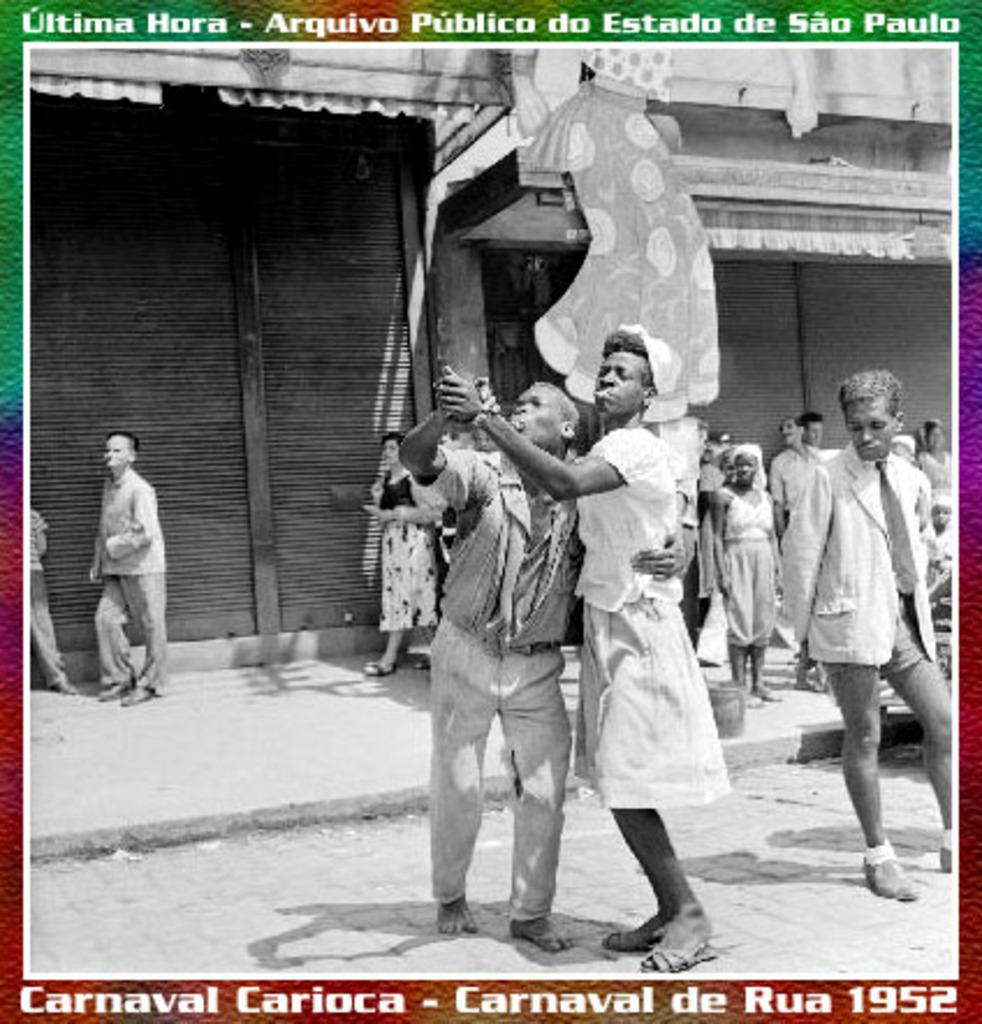What is present at the top and bottom of the image? There is text at the top and bottom of the image. What can be seen in the middle of the image? There are people in the middle of the image. What architectural feature is visible in the background of the image? There are shutters in the background of the image. What color is the paint on the stomach of the person in the image? There is no mention of paint or a person's stomach in the image, so this information cannot be determined. 